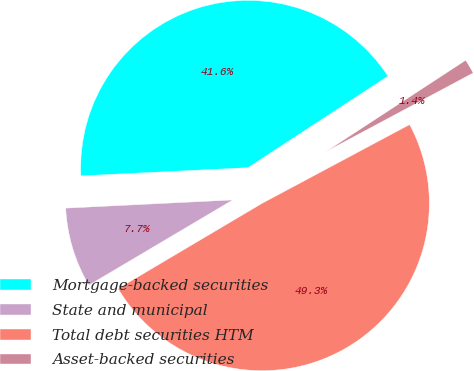<chart> <loc_0><loc_0><loc_500><loc_500><pie_chart><fcel>Mortgage-backed securities<fcel>State and municipal<fcel>Total debt securities HTM<fcel>Asset-backed securities<nl><fcel>41.56%<fcel>7.73%<fcel>49.29%<fcel>1.41%<nl></chart> 